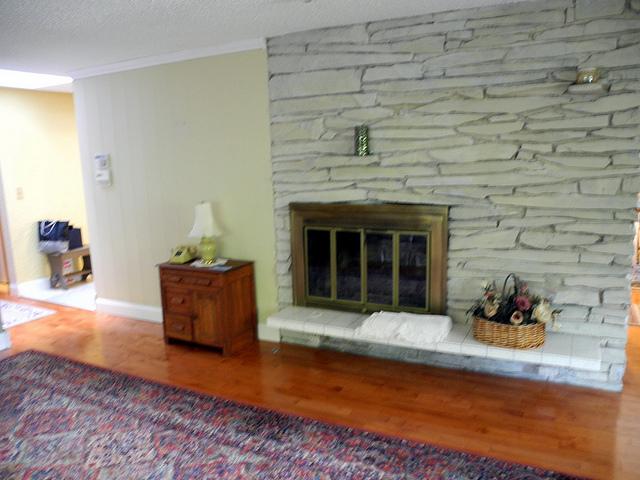How many sconces are visible?
Be succinct. 2. Does this home have good natural light?
Concise answer only. Yes. Why is there a picture in front of the fireplace?
Short answer required. There isn't. What color is the rug?
Short answer required. Purple. What does the brass container on the left side of the fireplace most likely contain?
Short answer required. Ashes. Is the photo frame on the far wall in the photo?
Short answer required. No. What is the color of the walls?
Concise answer only. Gray. Where are the artificial flowers?
Give a very brief answer. In basket. What red object is that on the floor?
Quick response, please. Rug. Is there a picture hanging on the wall?
Write a very short answer. No. Is this room possibly in an attic?
Short answer required. No. Is the plant in the right corner real?
Keep it brief. No. What pattern is the rug?
Give a very brief answer. Oriental. Is the table going to jump into the fireplace?
Write a very short answer. No. Is the fireplace centered in the stone section?
Be succinct. No. What type of flowers are shown?
Keep it brief. Fake. 